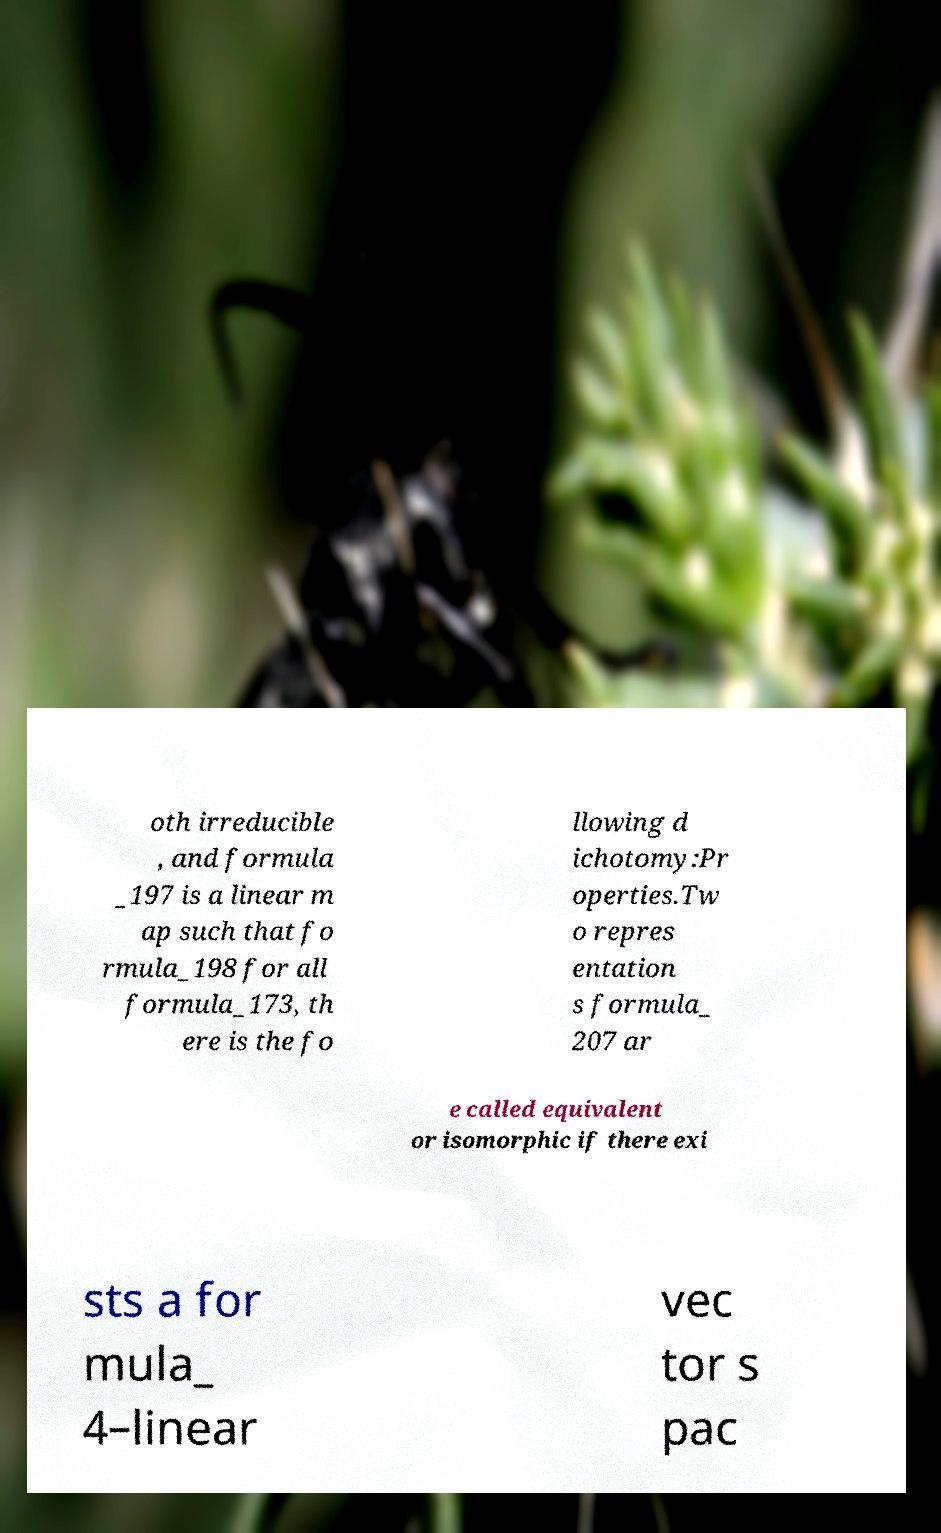Can you read and provide the text displayed in the image?This photo seems to have some interesting text. Can you extract and type it out for me? oth irreducible , and formula _197 is a linear m ap such that fo rmula_198 for all formula_173, th ere is the fo llowing d ichotomy:Pr operties.Tw o repres entation s formula_ 207 ar e called equivalent or isomorphic if there exi sts a for mula_ 4–linear vec tor s pac 